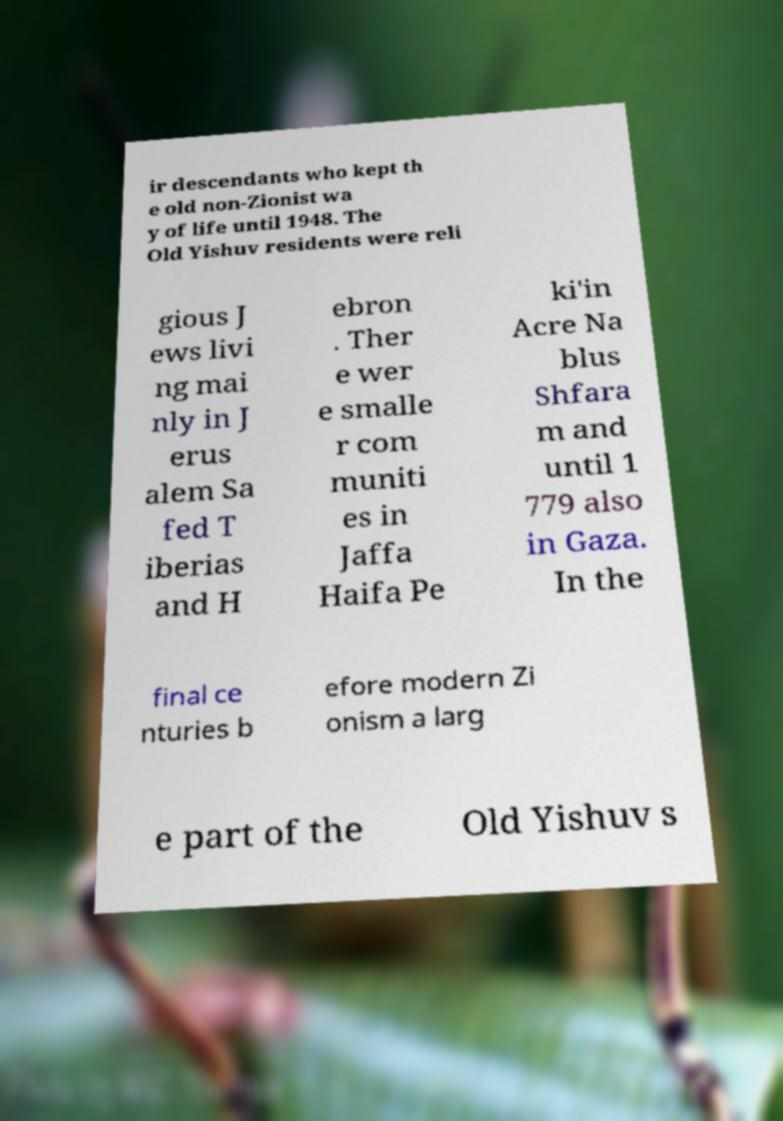Could you extract and type out the text from this image? ir descendants who kept th e old non-Zionist wa y of life until 1948. The Old Yishuv residents were reli gious J ews livi ng mai nly in J erus alem Sa fed T iberias and H ebron . Ther e wer e smalle r com muniti es in Jaffa Haifa Pe ki'in Acre Na blus Shfara m and until 1 779 also in Gaza. In the final ce nturies b efore modern Zi onism a larg e part of the Old Yishuv s 